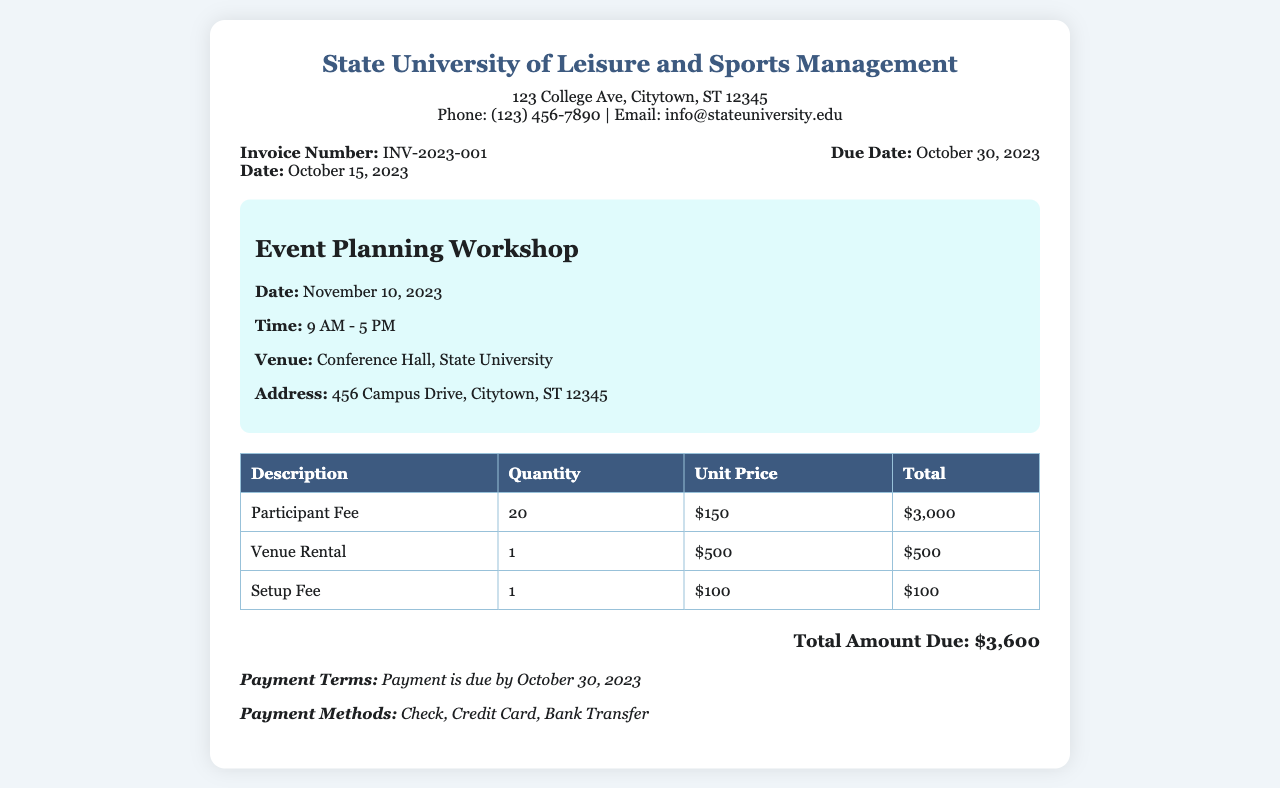what is the invoice number? The invoice number is listed at the top of the document to identify the transaction, which is INV-2023-001.
Answer: INV-2023-001 what is the total amount due? The total amount due is calculated at the bottom of the invoice, which includes participant fees and other costs, stated as $3,600.
Answer: $3,600 when is the workshop date? The workshop date is provided in the workshop details section, which is November 10, 2023.
Answer: November 10, 2023 what is the venue for the workshop? The venue is specified in the workshop details section as the Conference Hall, State University.
Answer: Conference Hall, State University how many participants are expected for the workshop? The expected number of participants is given in the itemized list, which states a quantity of 20.
Answer: 20 what is the setup fee? The setup fee is listed in the itemized costs section, using the unit price and quantity, which totals $100.
Answer: $100 which payment methods are accepted? The payment methods are mentioned in the payment terms section, providing options for payment: check, credit card, and bank transfer.
Answer: Check, Credit Card, Bank Transfer what is the due date for payment? The due date for payment is indicated in the invoice details section, which is October 30, 2023.
Answer: October 30, 2023 what is the address for the university? The address for the university is given in the header section of the document as 123 College Ave, Citytown, ST 12345.
Answer: 123 College Ave, Citytown, ST 12345 